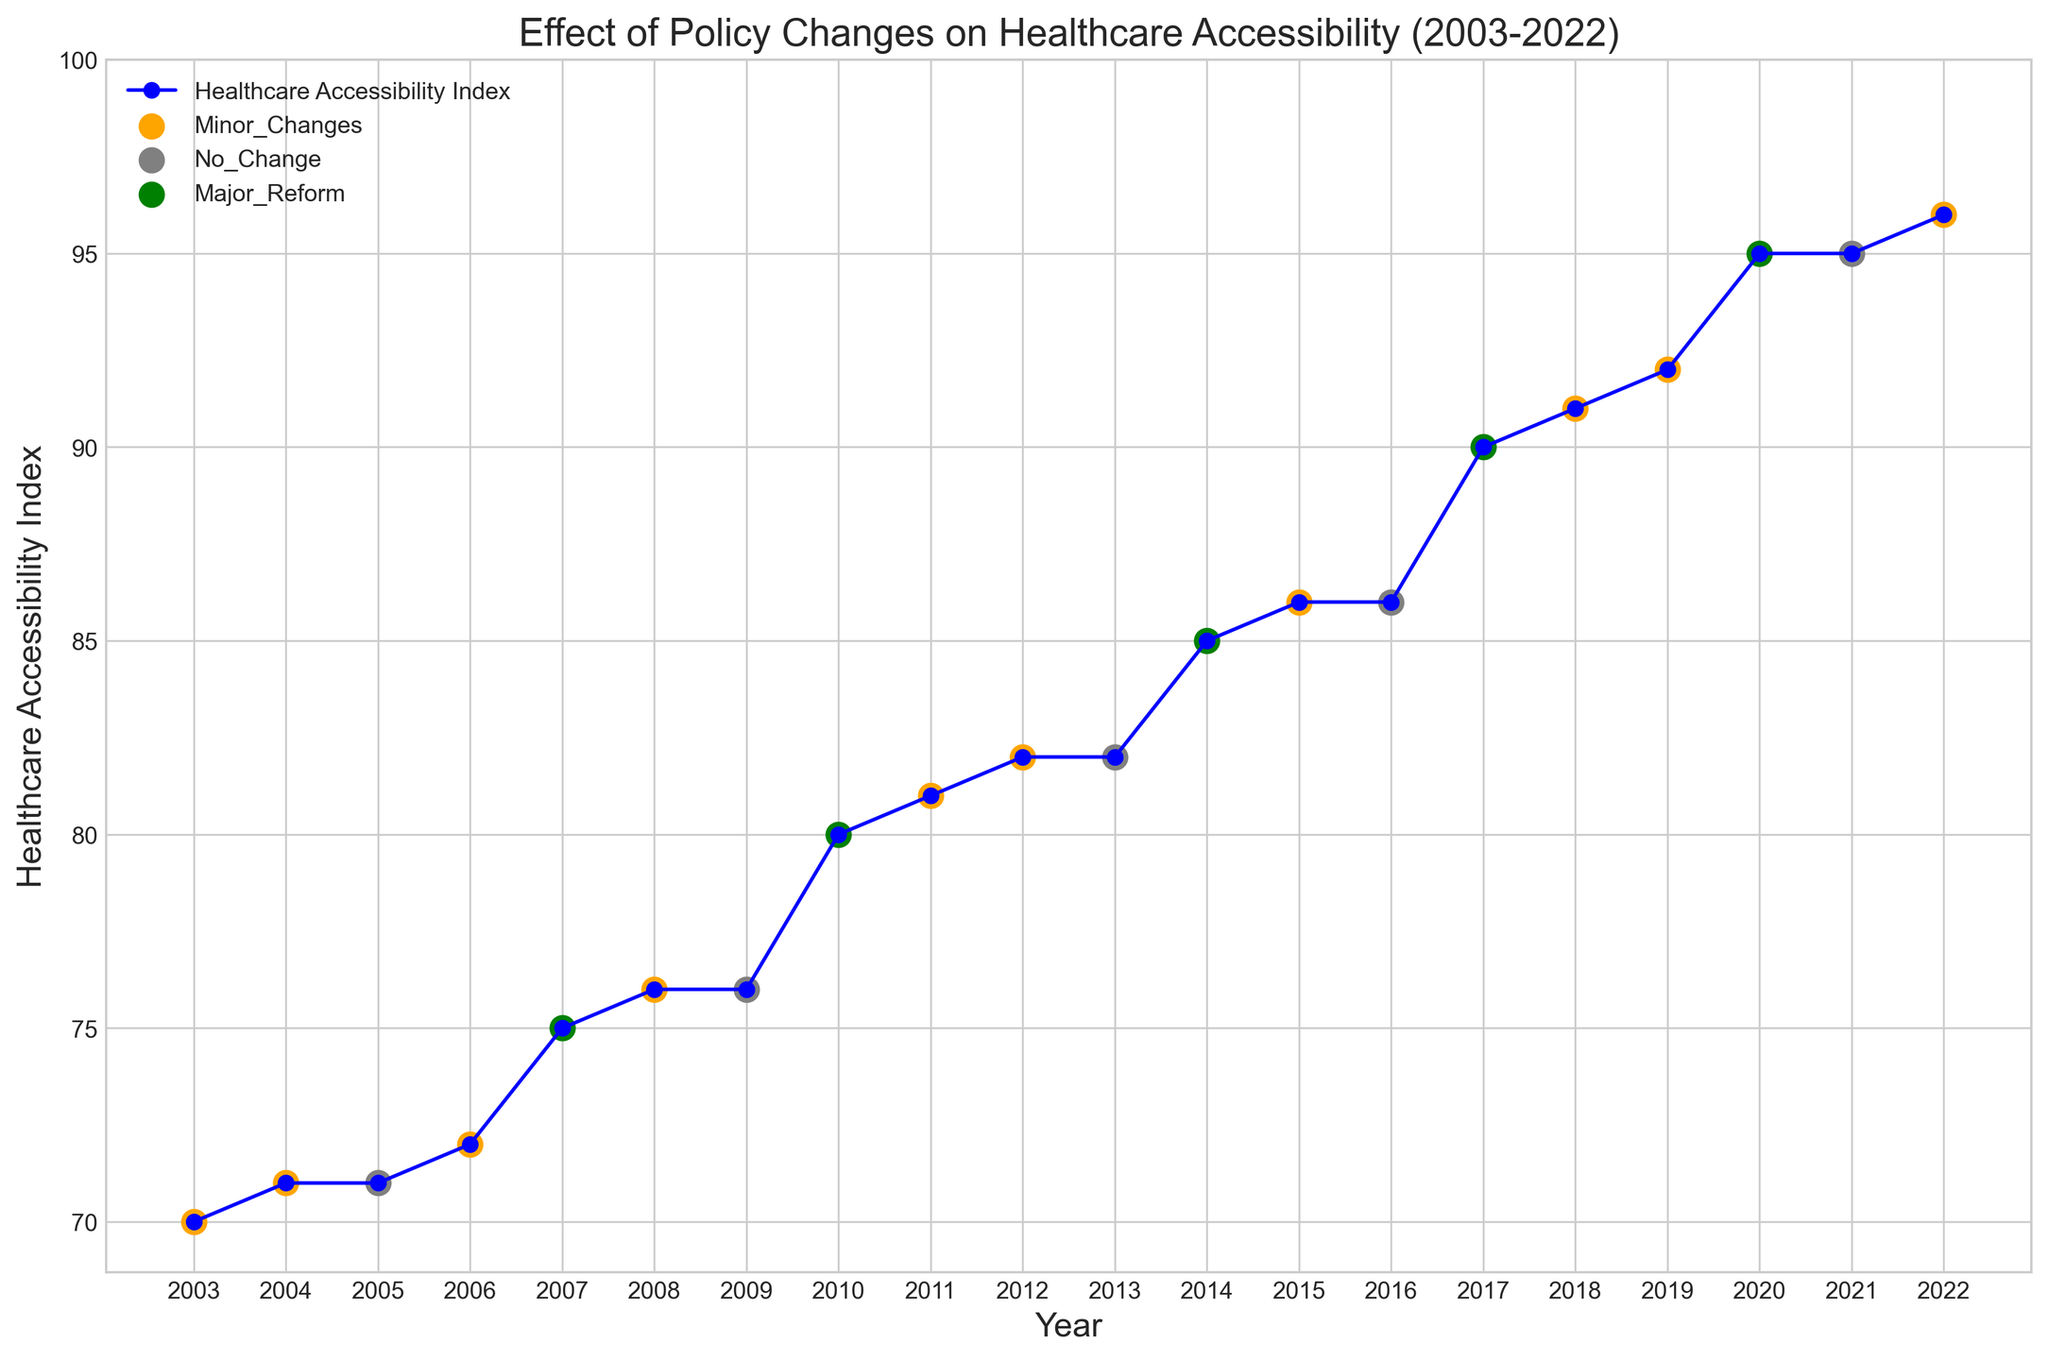When did the Healthcare Accessibility Index see the most significant increase? The most significant increase in the Healthcare Accessibility Index is observed between 2019 and 2020, where it jumps from 92 to 95. This period coincides with a Major Reform which likely contributed to the sharp rise.
Answer: 2019-2020 Which year witnessed the highest Healthcare Accessibility Index? The highest Healthcare Accessibility Index is in 2022, where the index reaches 96. This can be determined by observing the furthest data point along the vertical axis on the plot.
Answer: 2022 By how many points did the Healthcare Accessibility Index increase from 2003 to 2022? The Healthcare Accessibility Index in 2003 is 70 and in 2022 is 96. The increase is found by subtracting the 2003 value from the 2022 value: 96 - 70 = 26.
Answer: 26 What is the general trend of the Healthcare Accessibility Index over the 20 years? The general trend shows a steadily increasing Healthcare Accessibility Index over the 20 years, with notable peaks during Major Reforms.
Answer: Increasing How many times were there 'Major Reforms' within the data span, and how did they generally affect the index? There are 5 Major Reforms (2007, 2010, 2014, 2017, 2020). Each instance of Major Reform is associated with a noticeable increase in the Healthcare Accessibility Index, indicating a positive effect on healthcare accessibility.
Answer: 5 times, positive effect Compare the average Healthcare Accessibility Index during 'No Change' vs. 'Major Reform' years. The average index during 'No Change' years (2005, 2009, 2013, 2016, 2021) is (71+76+82+86+95)/5 = 82. The average during 'Major Reform' years (2007, 2010, 2014, 2017, 2020) is (75+80+85+90+95)/5 = 85.
Answer: 'No Change': 82, 'Major Reform': 85 What color represents 'Minor Changes' in the plot? In the plot, 'Minor Changes' are represented by the color orange. This can be identified by noting the color of scatter points and labels for 'Minor Changes' in the legend.
Answer: Orange Which years had no changes in policy, and what was the Healthcare Accessibility Index during those years? The 'No Change' years are 2005, 2009, 2013, 2016, 2021. The indices for these years are 71, 76, 82, 86, 95 respectively.
Answer: 2005: 71, 2009: 76, 2013: 82, 2016: 86, 2021: 95 During which policy change periods did the Healthcare Accessibility Index not change between consecutive years? There were 'No Change' in the index during 'No Change' periods from 2004 to 2005 (71) and from 2019 to 2020 (both 95).
Answer: 2004-2005, 2019-2020 What is the difference in the Healthcare Accessibility Index between the first and last Major Reform years? The first Major Reform year is 2007 with an index of 75, and the last Major Reform year is 2020 with an index of 95. The difference is calculated as 95 - 75 = 20.
Answer: 20 